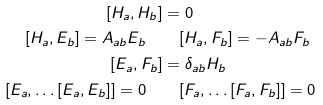Convert formula to latex. <formula><loc_0><loc_0><loc_500><loc_500>[ H _ { a } , H _ { b } ] & = 0 \\ [ H _ { a } , E _ { b } ] = A _ { a b } E _ { b } \quad & \quad [ H _ { a } , F _ { b } ] = - A _ { a b } F _ { b } \\ [ E _ { a } , F _ { b } ] & = \delta _ { a b } H _ { b } \\ [ E _ { a } , \dots [ E _ { a } , E _ { b } ] ] = 0 \quad & \quad [ F _ { a } , \dots [ F _ { a } , F _ { b } ] ] = 0</formula> 